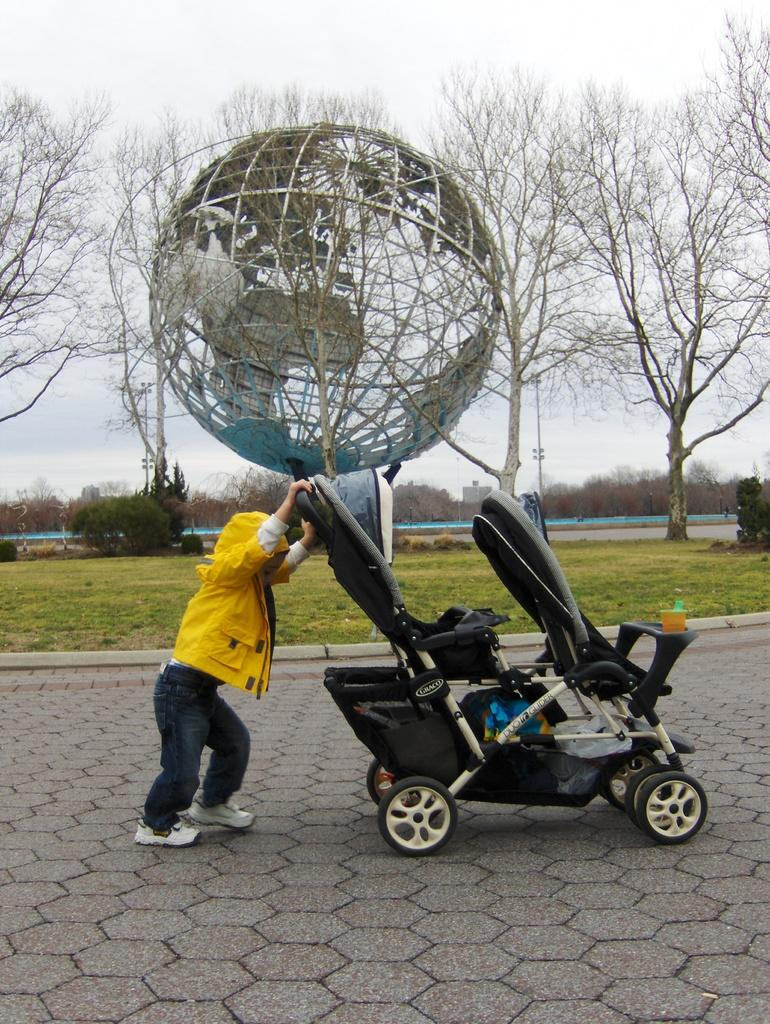Who is the main subject in the image? There is a little boy in the image. What is the boy doing in the image? The boy is pushing a Walker in the image. Where is the Walker located in the image? The Walker is on a path on the ground in the image. What type of natural environment is visible in the image? There are trees, grass, and plants on the ground in the image. What is visible in the background of the image? The sky is visible in the background of the image. What type of bag is the little boy carrying in the image? There is no bag visible in the image; the little boy is pushing a Walker. 